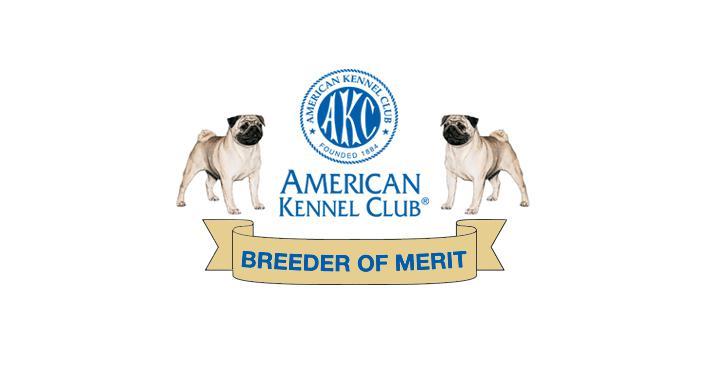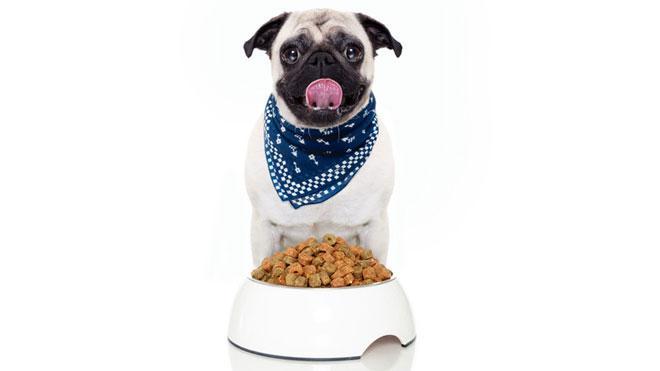The first image is the image on the left, the second image is the image on the right. Considering the images on both sides, is "The left image shows a pug with something edible in front of him, and the right image shows a pug in a collared shirt with a bowl in front of him." valid? Answer yes or no. No. The first image is the image on the left, the second image is the image on the right. Examine the images to the left and right. Is the description "A dog has a white dish in front of him." accurate? Answer yes or no. Yes. 